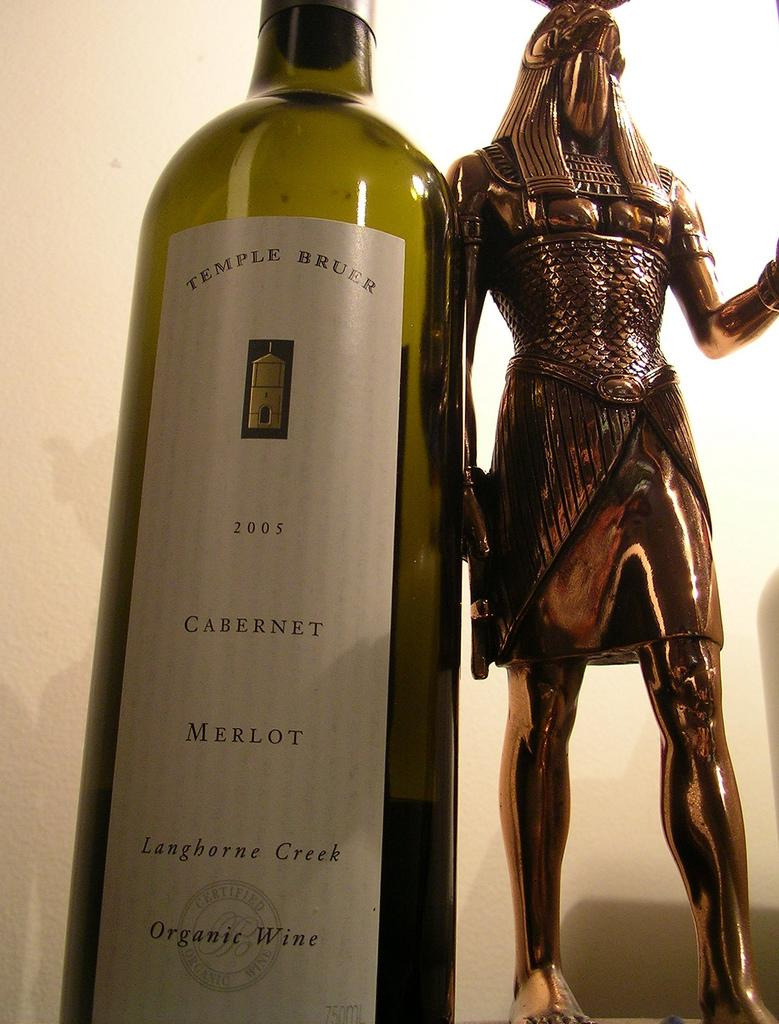<image>
Share a concise interpretation of the image provided. A bottle of Langhorne Creek Cabernet Merlot organic wine next to a bronze statue. 